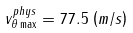<formula> <loc_0><loc_0><loc_500><loc_500>v _ { \theta \max } ^ { p h y s } = 7 7 . 5 \, \left ( m / s \right )</formula> 